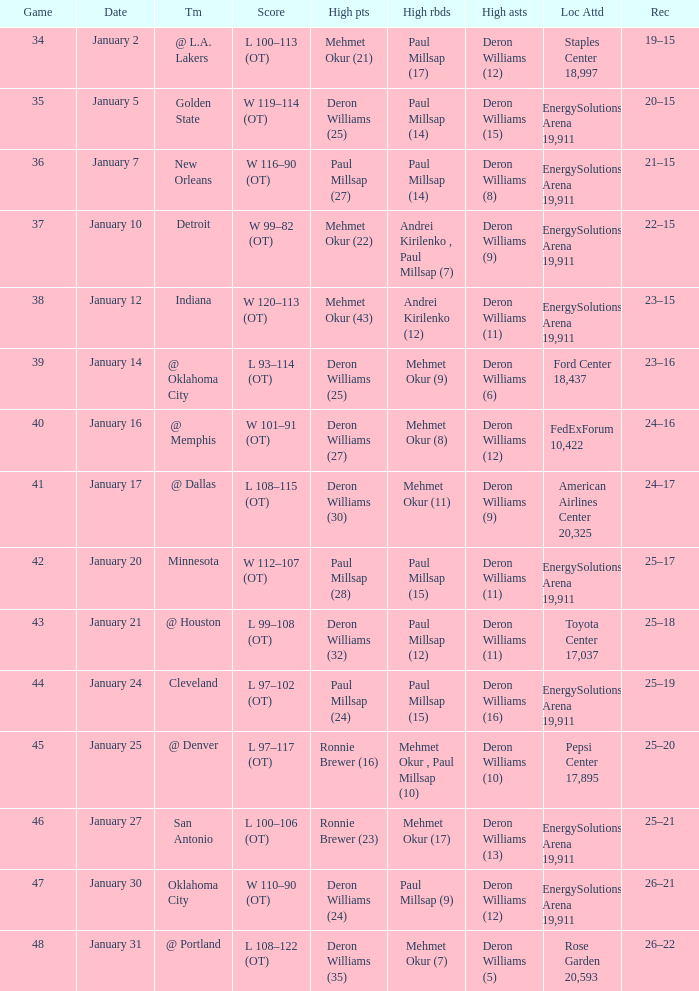Who had the high rebounds on January 24? Paul Millsap (15). 